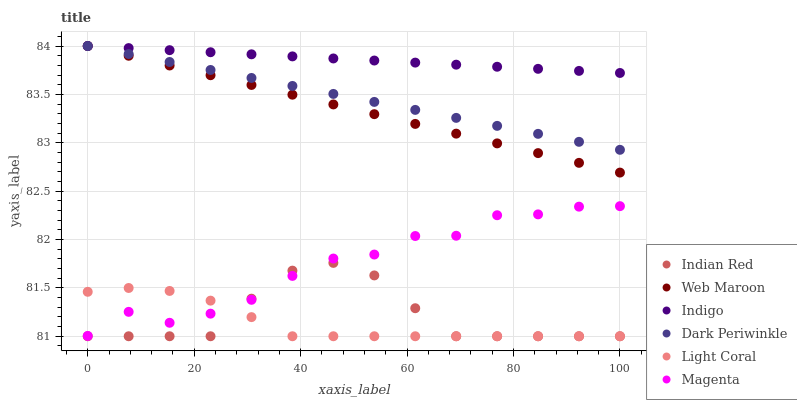Does Light Coral have the minimum area under the curve?
Answer yes or no. Yes. Does Indigo have the maximum area under the curve?
Answer yes or no. Yes. Does Web Maroon have the minimum area under the curve?
Answer yes or no. No. Does Web Maroon have the maximum area under the curve?
Answer yes or no. No. Is Indigo the smoothest?
Answer yes or no. Yes. Is Magenta the roughest?
Answer yes or no. Yes. Is Web Maroon the smoothest?
Answer yes or no. No. Is Web Maroon the roughest?
Answer yes or no. No. Does Light Coral have the lowest value?
Answer yes or no. Yes. Does Web Maroon have the lowest value?
Answer yes or no. No. Does Dark Periwinkle have the highest value?
Answer yes or no. Yes. Does Light Coral have the highest value?
Answer yes or no. No. Is Light Coral less than Indigo?
Answer yes or no. Yes. Is Dark Periwinkle greater than Light Coral?
Answer yes or no. Yes. Does Indian Red intersect Light Coral?
Answer yes or no. Yes. Is Indian Red less than Light Coral?
Answer yes or no. No. Is Indian Red greater than Light Coral?
Answer yes or no. No. Does Light Coral intersect Indigo?
Answer yes or no. No. 